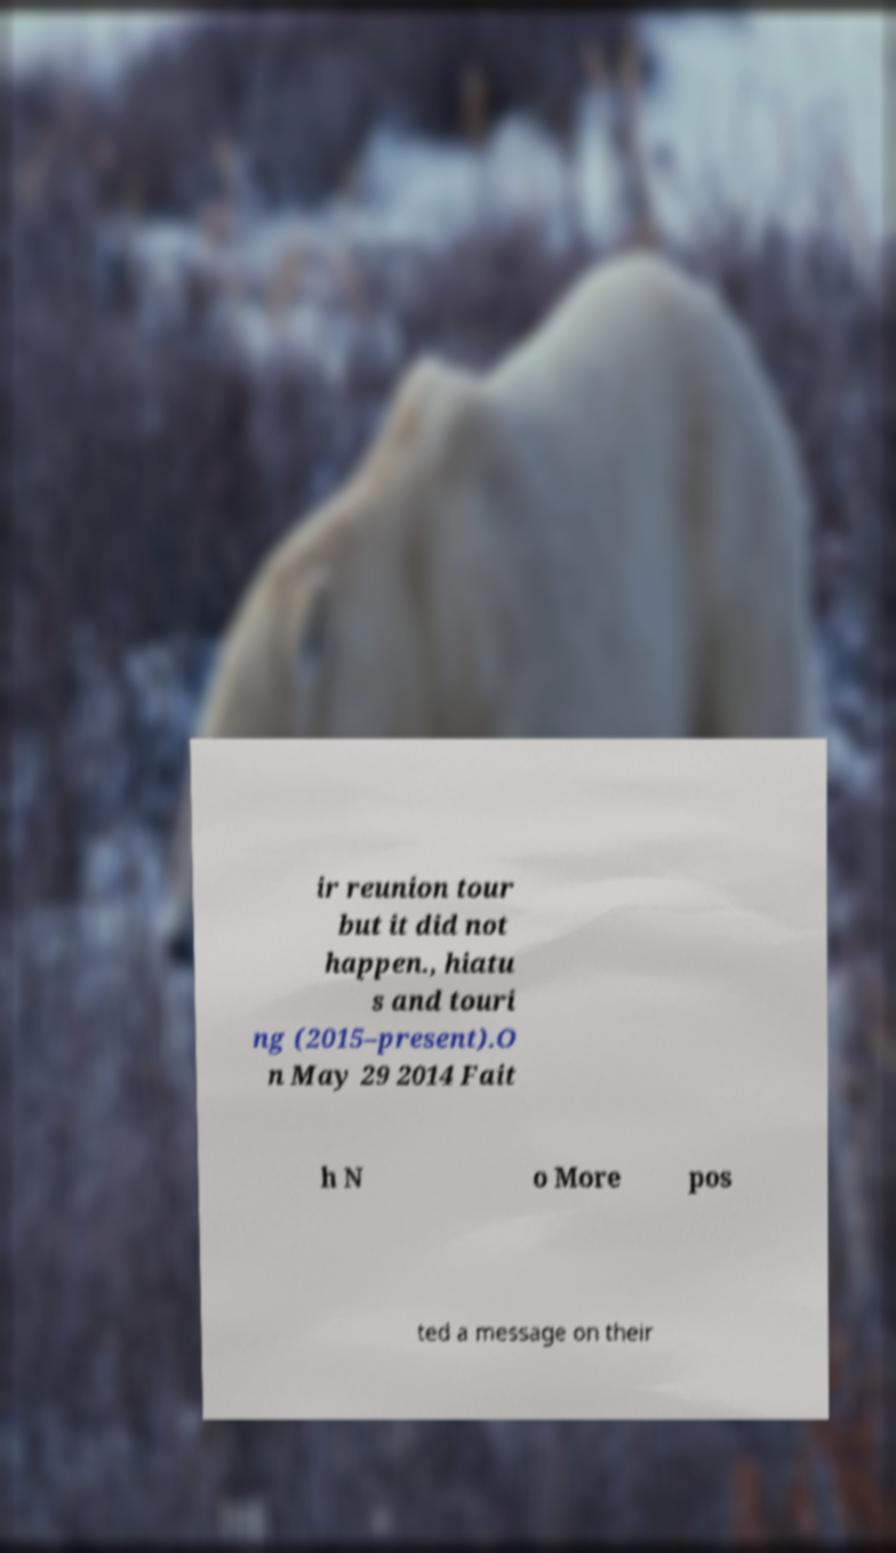Could you extract and type out the text from this image? ir reunion tour but it did not happen., hiatu s and touri ng (2015–present).O n May 29 2014 Fait h N o More pos ted a message on their 